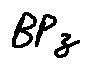Convert formula to latex. <formula><loc_0><loc_0><loc_500><loc_500>B P z</formula> 